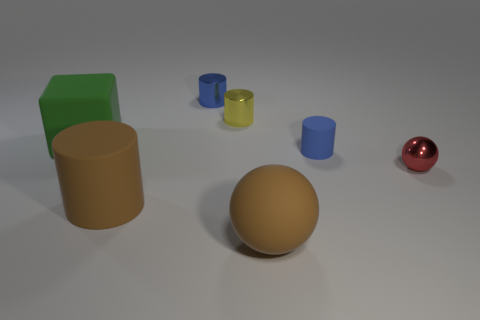Is there a thing that is behind the small blue rubber thing that is in front of the small yellow metal cylinder?
Offer a terse response. Yes. There is another blue object that is the same shape as the small matte thing; what material is it?
Your response must be concise. Metal. There is a small cylinder that is in front of the green thing; how many large green things are on the right side of it?
Provide a succinct answer. 0. Is there anything else of the same color as the matte block?
Provide a succinct answer. No. How many things are either yellow objects or brown matte things that are right of the cube?
Provide a succinct answer. 3. The big thing behind the small red ball that is behind the ball in front of the red metal ball is made of what material?
Ensure brevity in your answer.  Rubber. What is the size of the blue object that is the same material as the big cylinder?
Offer a very short reply. Small. There is a rubber thing that is on the left side of the cylinder that is on the left side of the blue metallic thing; what color is it?
Your answer should be compact. Green. What number of green objects are made of the same material as the small yellow object?
Ensure brevity in your answer.  0. What number of metal objects are big cyan balls or small red balls?
Provide a short and direct response. 1. 